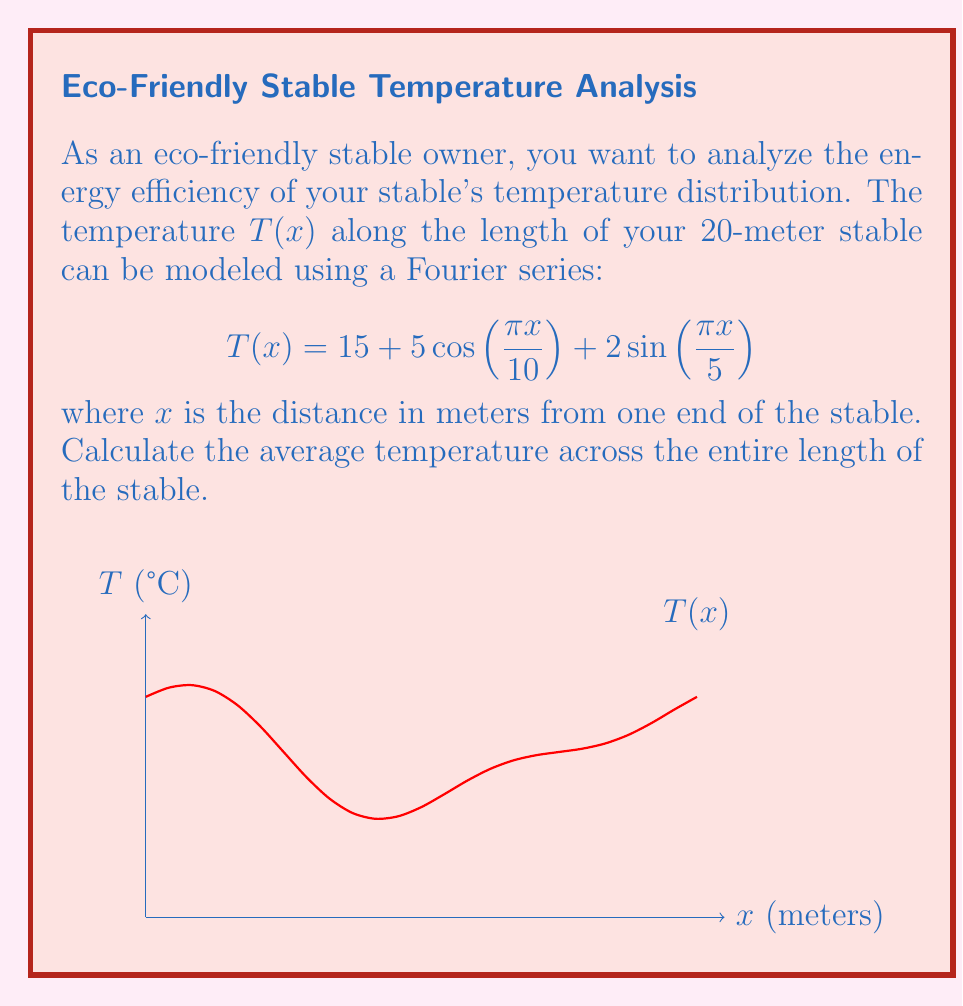Can you solve this math problem? To find the average temperature, we need to integrate the temperature function over the length of the stable and divide by the total length. Here's how we do it step-by-step:

1) The average temperature is given by:
   $$T_{avg} = \frac{1}{L}\int_0^L T(x)dx$$
   where $L = 20$ meters (the length of the stable).

2) Substitute the given function:
   $$T_{avg} = \frac{1}{20}\int_0^{20} (15 + 5\cos(\frac{\pi x}{10}) + 2\sin(\frac{\pi x}{5}))dx$$

3) We can integrate each term separately:
   $$T_{avg} = \frac{1}{20}[15x + \frac{50}{\pi/10}\sin(\frac{\pi x}{10}) - \frac{10}{\pi/5}\cos(\frac{\pi x}{5})]_0^{20}$$

4) Evaluate the integral:
   $$T_{avg} = \frac{1}{20}[(15 \cdot 20 + \frac{50}{\pi/10}\sin(2\pi) - \frac{10}{\pi/5}\cos(4\pi)) - (0 + 0 - \frac{10}{\pi/5})]$$

5) Simplify:
   $$T_{avg} = \frac{1}{20}[300 + 0 - \frac{10}{\pi/5} + \frac{10}{\pi/5}]$$

6) The sine and cosine terms evaluate to 0 and 1 respectively at the limits, so they cancel out.

7) We're left with:
   $$T_{avg} = \frac{300}{20} = 15$$
Answer: 15°C 